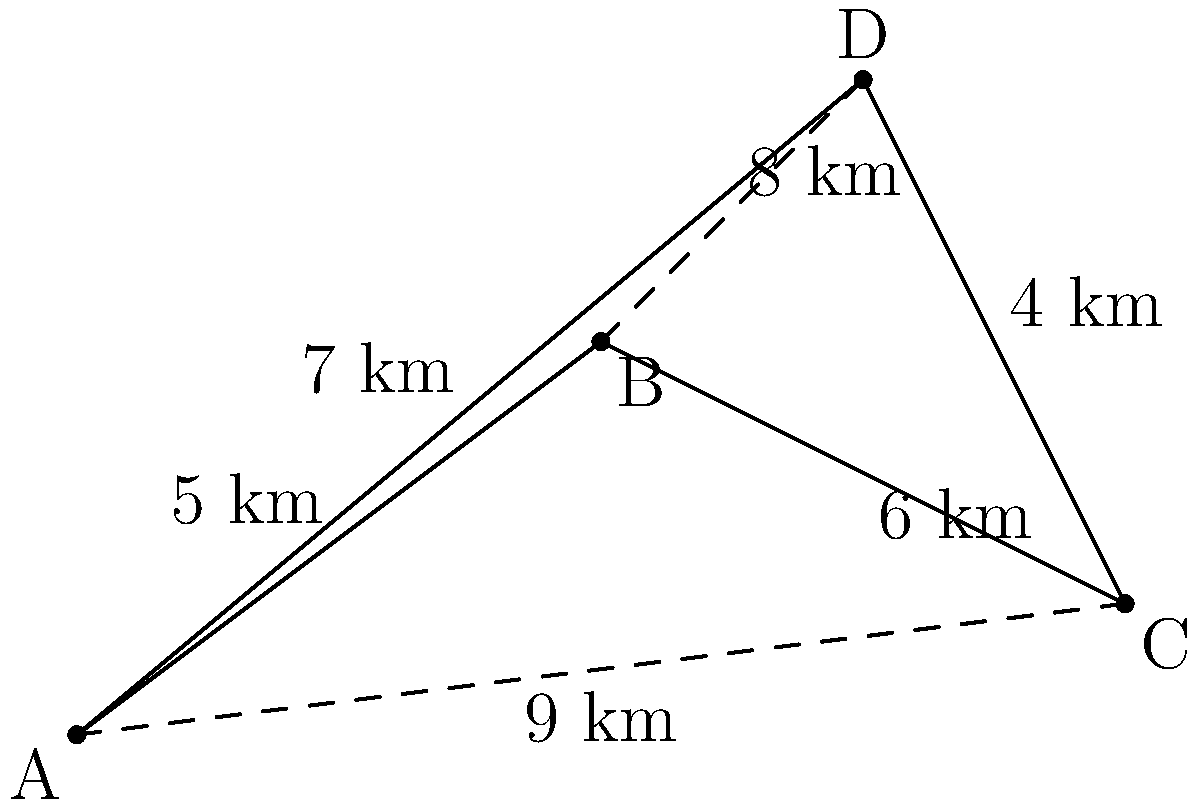As a concerned local resident in western Sydney, you're aware of the importance of efficient emergency services. The diagram shows a simplified map of four suburbs (A, B, C, and D) with distances between them. An ambulance needs to travel from suburb A to suburb C. Which route should it take to minimize travel time, and what is the total distance of this route? To determine the most efficient route from A to C, we need to compare the possible paths:

1. Direct route A to C:
   Distance = 9 km

2. Route A-B-C:
   Distance = 5 km + 6 km = 11 km

3. Route A-D-C:
   Distance = 7 km + 4 km = 11 km

Step 1: Compare the distances
The direct route A to C (9 km) is shorter than both A-B-C (11 km) and A-D-C (11 km).

Step 2: Consider road conditions
Although not explicitly stated, we can assume that the direct route between suburbs might not always be the fastest due to potential traffic or road quality issues. However, without this information, we must rely on the given distances.

Step 3: Determine the most efficient route
Based on the available information, the most efficient route is the direct path from A to C.

Step 4: Calculate the total distance
The total distance of the most efficient route is 9 km.
Answer: Direct route A to C; 9 km 